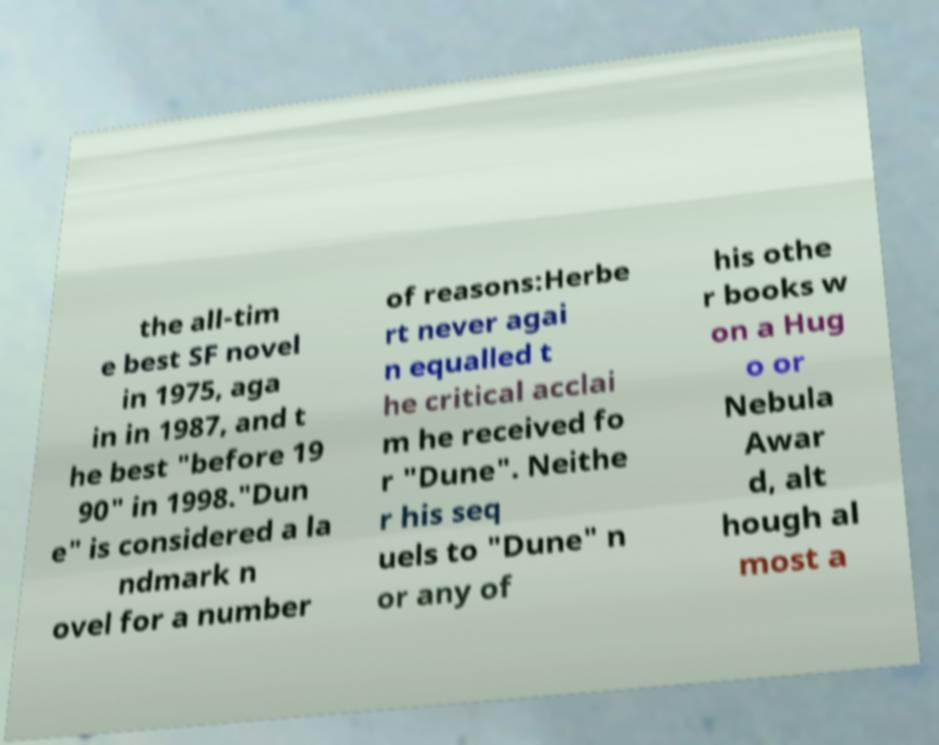Could you extract and type out the text from this image? the all-tim e best SF novel in 1975, aga in in 1987, and t he best "before 19 90" in 1998."Dun e" is considered a la ndmark n ovel for a number of reasons:Herbe rt never agai n equalled t he critical acclai m he received fo r "Dune". Neithe r his seq uels to "Dune" n or any of his othe r books w on a Hug o or Nebula Awar d, alt hough al most a 